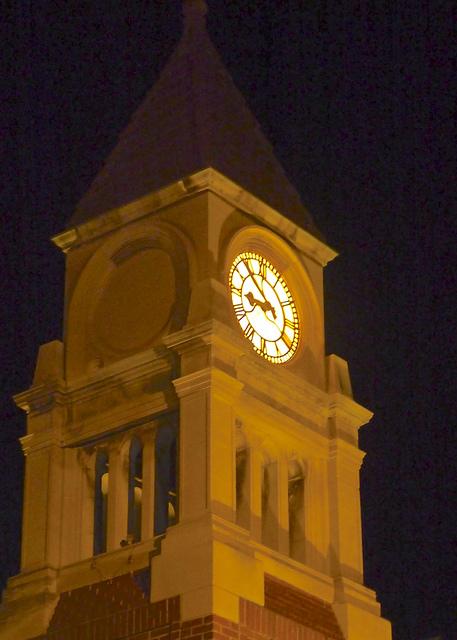What color is the sky?
Answer briefly. Black. What time does the clock read?
Keep it brief. 8:55. What time does the clock say?
Write a very short answer. 8:55. What color is the building?
Keep it brief. White. Are the windows stained glass?
Short answer required. No. Is this a building or clock tower?
Be succinct. Clock tower. How many clocks are shown on the building?
Quick response, please. 1. How many clocks can you see?
Short answer required. 1. Is the building made of brick?
Give a very brief answer. Yes. Is this building less than 50 years old?
Write a very short answer. No. What time is it?
Concise answer only. 8:55. 